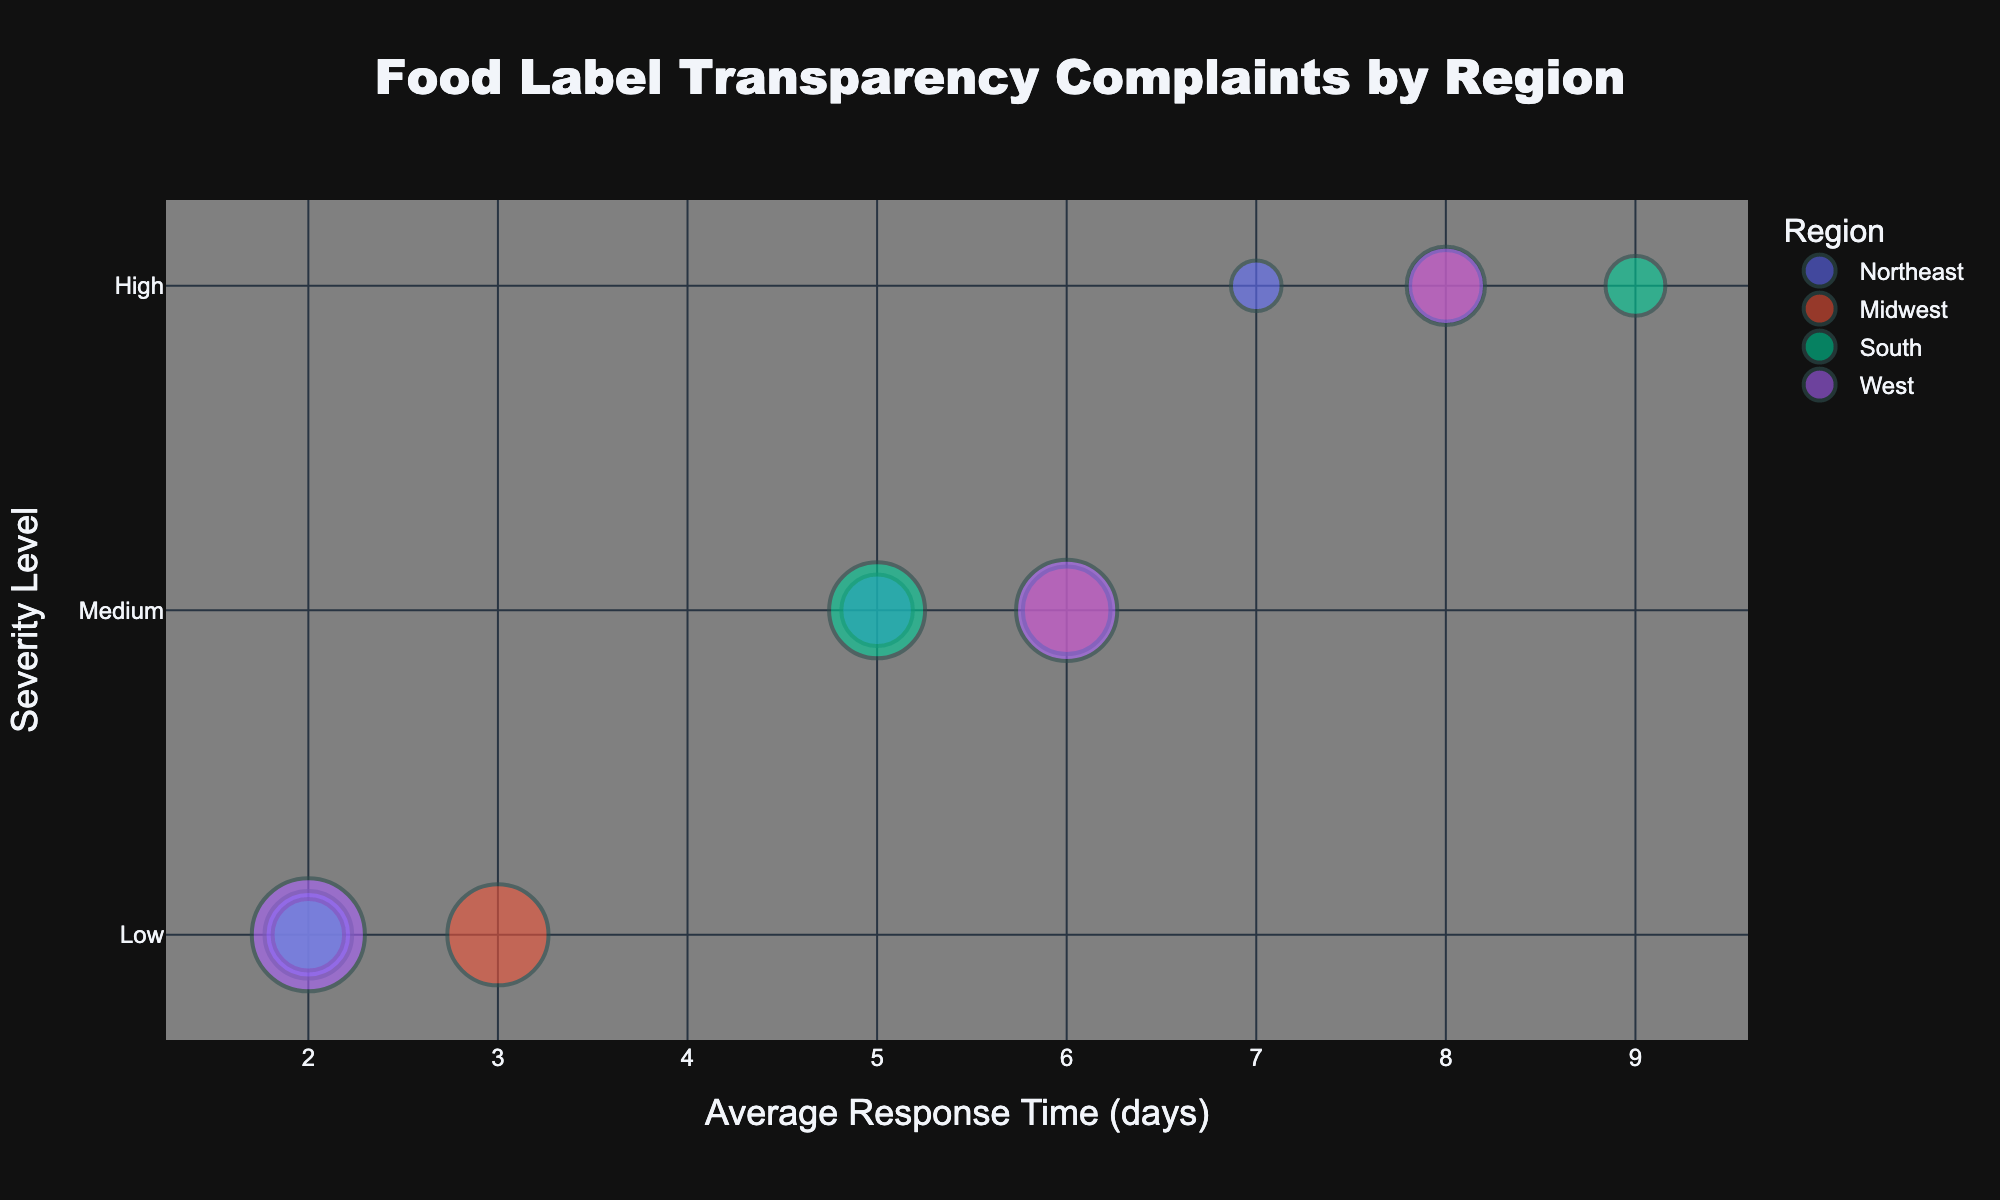How many regions are represented in the bubble chart? The legend on the bubble chart lists the distinct regions represented in the data. By counting these regions, we can determine that there are four unique regions visualized in the chart: Northeast, Midwest, South, and West.
Answer: 4 What is the average response time for high-severity complaints in the South region? By looking at the South region and filtering for high-severity complaints, the corresponding bubble for high-severity should state the average response time in its hover text, which is 9 days according to the data.
Answer: 9 days Which region has the highest number of low-severity complaints? The size of the bubbles indicates the number of complaints, and by checking the bubbles for low-severity across regions, we can see that the West region has the largest bubble, indicating it has the highest number of low-severity complaints.
Answer: West If you add up all low-severity complaints in the Northeast and Midwest regions, what is the total? The data shows that the Northeast has 15 low-severity complaints and the Midwest has 20. Adding these together gives a total of 35 low-severity complaints.
Answer: 35 Which region has a higher average response time for medium-severity complaints, Northeast or South? By comparing the medium-severity bubbles for the Northeast and South regions, the chart indicates that the Northeast has an average response time of 5 days while the South has 5 days as well.
Answer: They are equal What is the sum of high-severity complaints across all regions? Adding up the high-severity complaints from each region: Northeast (5), Midwest (10), South (7), and West (12), we get a total of 34.
Answer: 34 Which region has the smallest bubble for low-severity complaints? Evaluating the size of the low-severity bubbles for each region, it is apparent that the South region has the smallest bubble, indicating it has the fewest low-severity complaints.
Answer: South What is the severity level with the most complaints in the West region? By examining the size of the bubbles in the West region, the low-severity bubble appears to be the largest, indicating it has the most complaints at that severity level in the West.
Answer: Low Comparing the Midwest and West regions, which has a higher total count of complaints for medium-severity? The data shows the Midwest has 15 medium-severity complaints and the West has 20. By summing each, we see the West has a higher total for medium-severity complaints.
Answer: West For high-severity complaints, how many more complaints does the West have compared to the Northeast? The data indicates that the West has 12 high-severity complaints, and the Northeast has 5. The difference is 7 complaints.
Answer: 7 